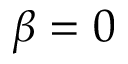Convert formula to latex. <formula><loc_0><loc_0><loc_500><loc_500>\beta = 0</formula> 